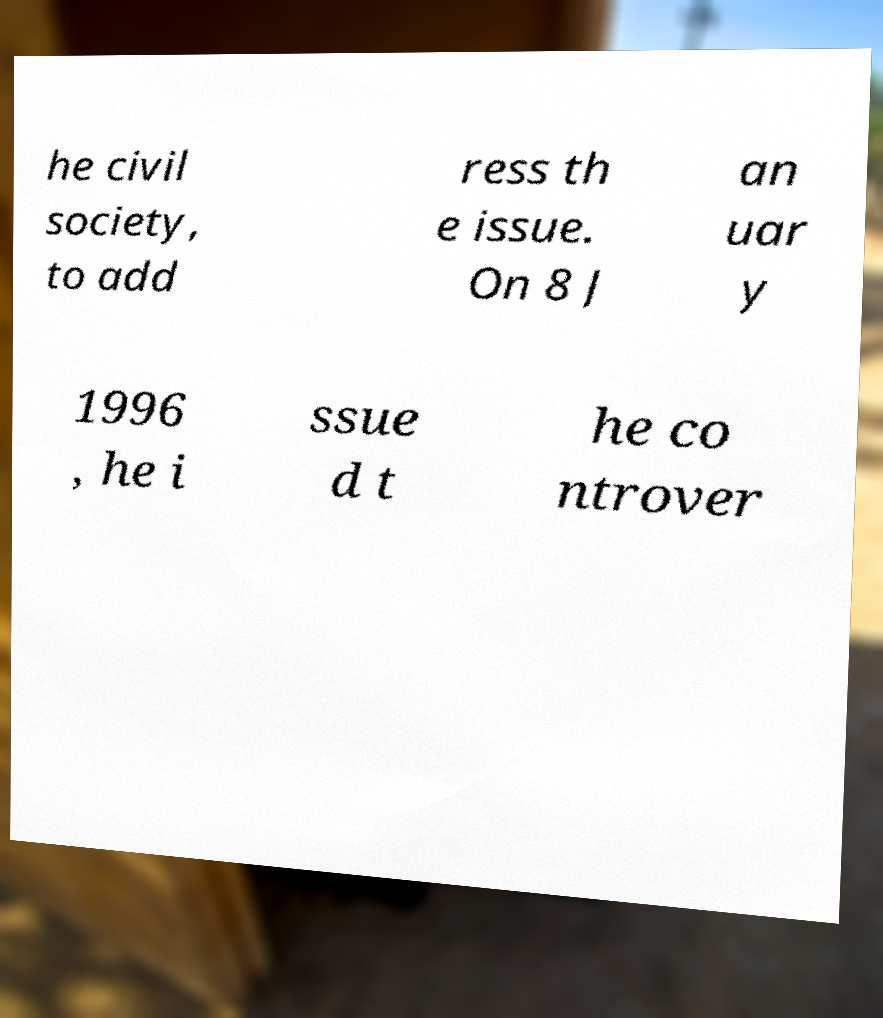Could you extract and type out the text from this image? he civil society, to add ress th e issue. On 8 J an uar y 1996 , he i ssue d t he co ntrover 